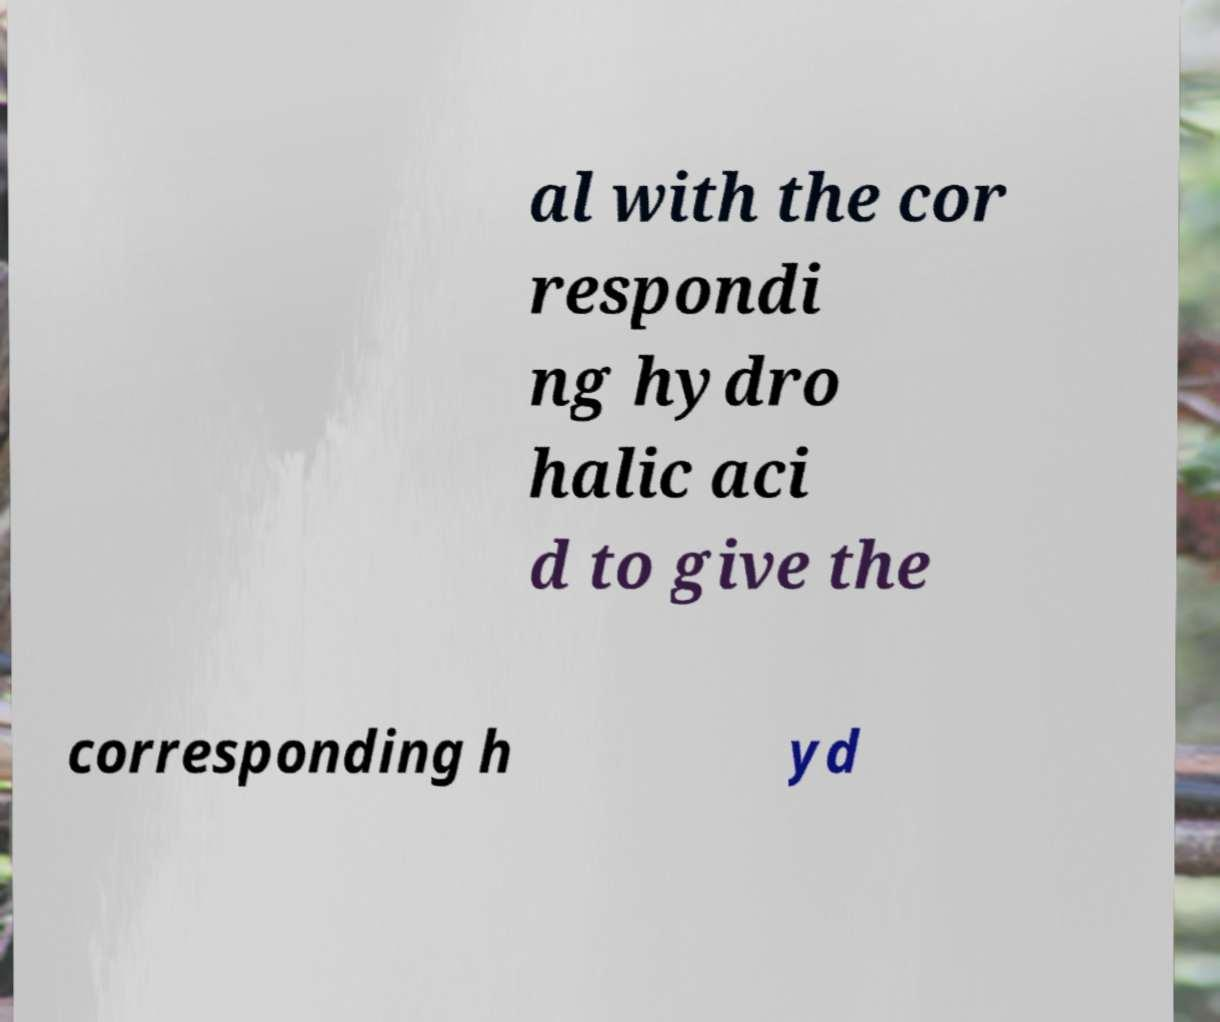What messages or text are displayed in this image? I need them in a readable, typed format. al with the cor respondi ng hydro halic aci d to give the corresponding h yd 